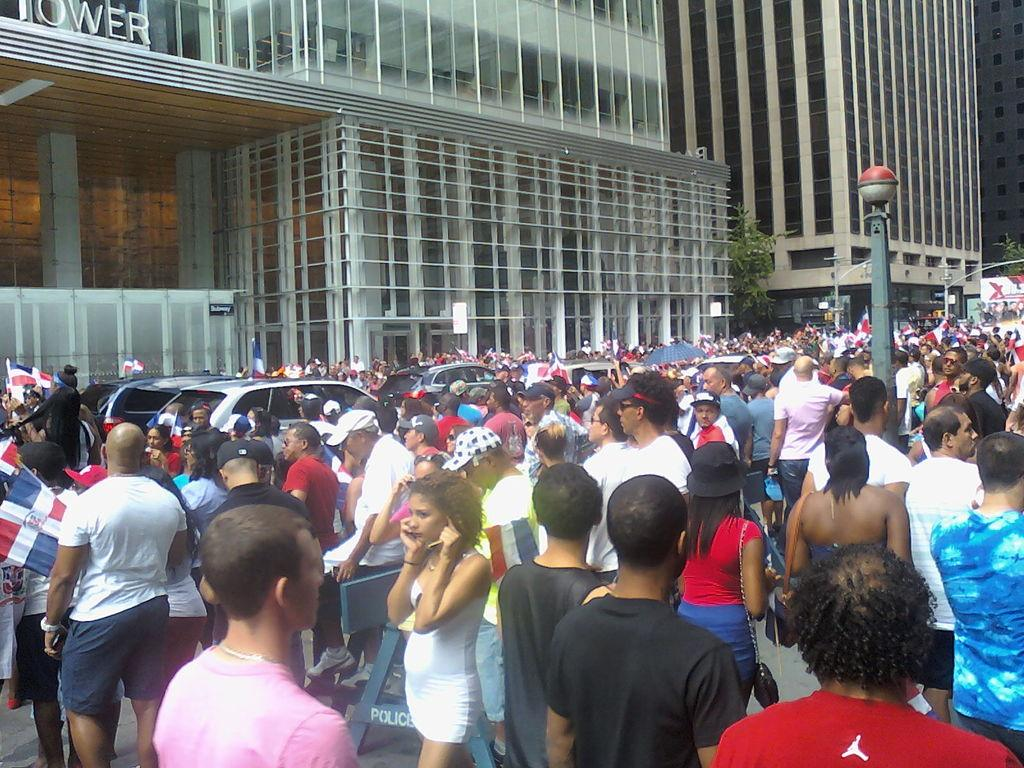What can be seen in the image? There are people standing in the image, along with cars and buildings in the background. Can you describe the people in the image? The provided facts do not give specific details about the people, so we cannot describe them further. What type of vehicles are present in the image? The image contains cars. Reasoning: Let's think step by following the guidelines to produce the conversation. We start by identifying the main subjects in the image, which are the people, cars, and buildings. Then, we formulate questions that focus on these subjects, ensuring that each question can be answered definitively with the information given. We avoid yes/no questions and ensure that the language is simple and clear. Absurd Question/Answer: What causes the cars to burst in the image? There is no indication in the image that the cars are bursting or experiencing any issues. 